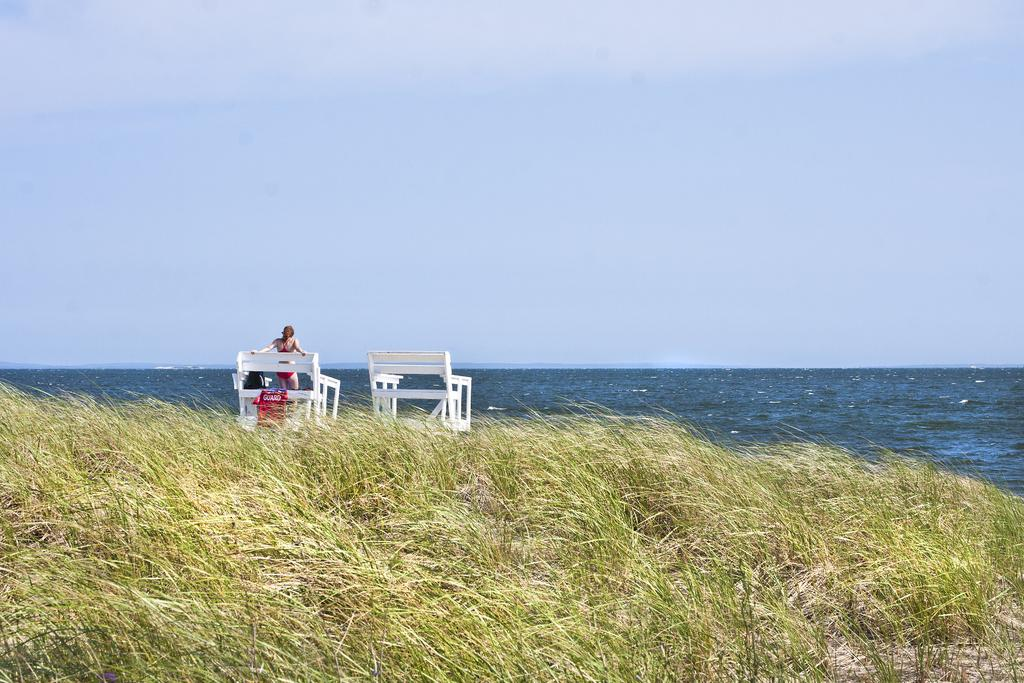What type of natural elements can be seen on the ground in the image? There are branches and grass on the ground in the image. What is the woman in the image doing? The woman is standing on a bench in the image. What can be seen in the image besides the woman and the bench? There is water visible in the image. What is visible at the top of the image? The sky is visible at the top of the image. What type of cheese is the woman holding in the image? There is no cheese present in the image; the woman is standing on a bench. What kind of banana can be seen in the water in the image? There is no banana present in the image; the water is visible but does not contain any fruit. 